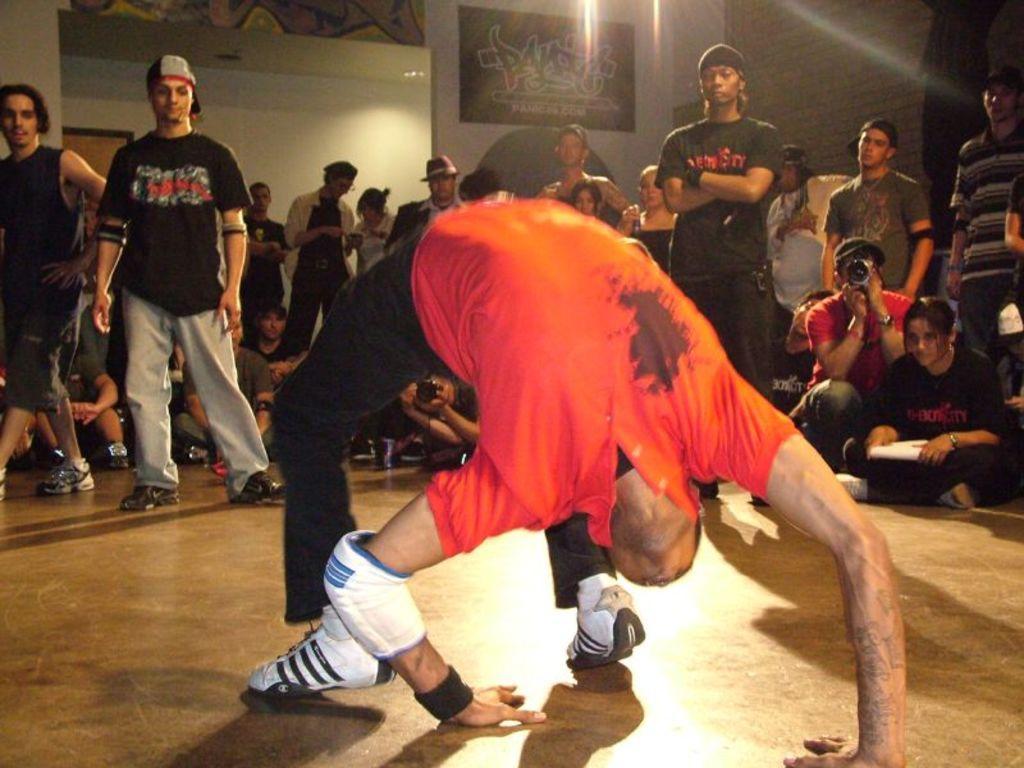Please provide a concise description of this image. In this image I can see the group of people with different color dresses. I can see few people with the caps and one person holding the camera. In the background I can see the boards and the wall. 